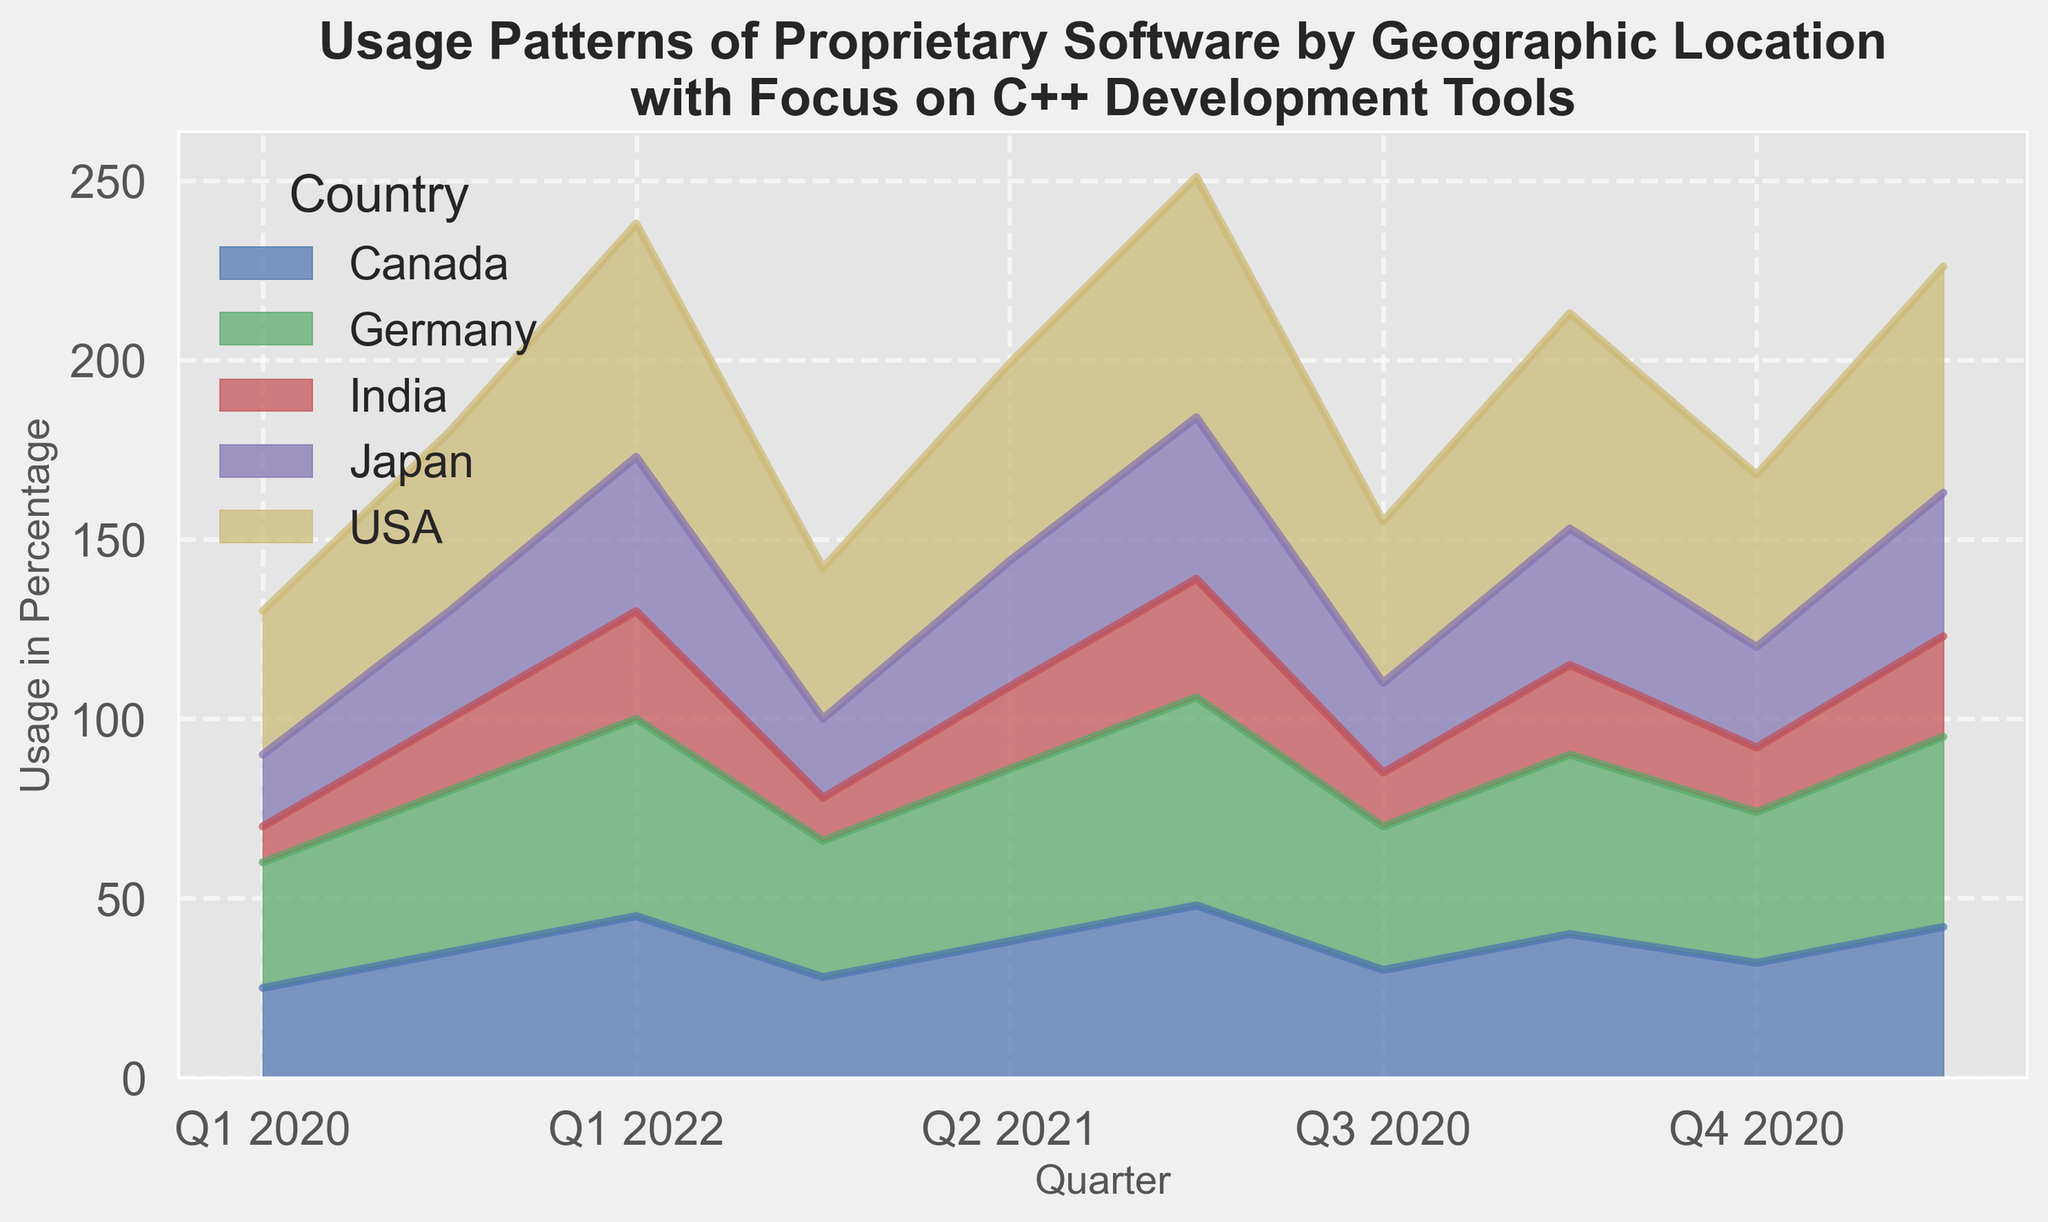What's the increase in the usage percentage of proprietary software in the USA from Q1 2020 to Q2 2022? To find the increase, subtract the Q1 2020 usage percentage from the Q2 2022 usage percentage. Q2 2022 usage in the USA is 67%, and Q1 2020 usage is 40%. Therefore, 67 - 40 = 27
Answer: 27% Comparing Q2 2022, which country has the highest usage percentage of proprietary software? Observe the Q2 2022 values for all countries in the chart. The USA has 67%, Germany has 58%, Japan has 45%, India has 33%, and Canada has 48%. The highest value is observed for the USA.
Answer: USA Which country had the most consistent increase in proprietary software usage over all quarters displayed? Consistency in increase means an almost linear and steady rise without major fluctuations. Check each country's area segment in the chart for smoothness. Germany and Japan show a fairly consistent rise, with Germany showing a steady linear trend.
Answer: Germany What's the difference in proprietary software usage percentage between Japan and India in Q4 2021? Look at the Q4 2021 values for Japan and India. Japan’s usage is 40%, and India’s usage is 28%. Calculate the difference: 40 - 28 = 12
Answer: 12% Which country's usage reached 50% first and in which quarter? Trace the regions where the usage reached 50%. The USA reached 50% before any other country, in Q1 2021.
Answer: USA, Q1 2021 By how much did Canada’s proprietary software usage increase from Q1 2020 to Q1 2022? Subtract Canada’s Q1 2020 usage percentage from its Q1 2022 usage percentage. Q1 2020 usage is 25%, and Q1 2022 usage is 45%. Therefore, 45 - 25 = 20
Answer: 20% How did India's proprietary software usage change from Q2 2020 to Q4 2021? Note India’s usage in Q2 2020 (12%) and in Q4 2021 (28%). The increase is 28 - 12 = 16
Answer: 16% In which quarter did Germany's proprietary software usage surpass 50% for the first time? Look for the first point where Germany's usage percentage exceeds 50%. This occurred in Q3 2021 when the usage reached 50% exactly and was surpassed in the next quarter.
Answer: Q4 2021 Which two countries had nearly the same usage in Q4 2021 and what was the value? Compare Q4 2021 usage percentages. Japan (40%) and Canada (42%) are closest, but not close enough. Germany (53%) and Canada (42%) are not close. Therefore, USA (63%) and Germany (53%) are the closest comparison but still not equal. Thus no two countries have nearly the same value for Q4 2021.
Answer: None 